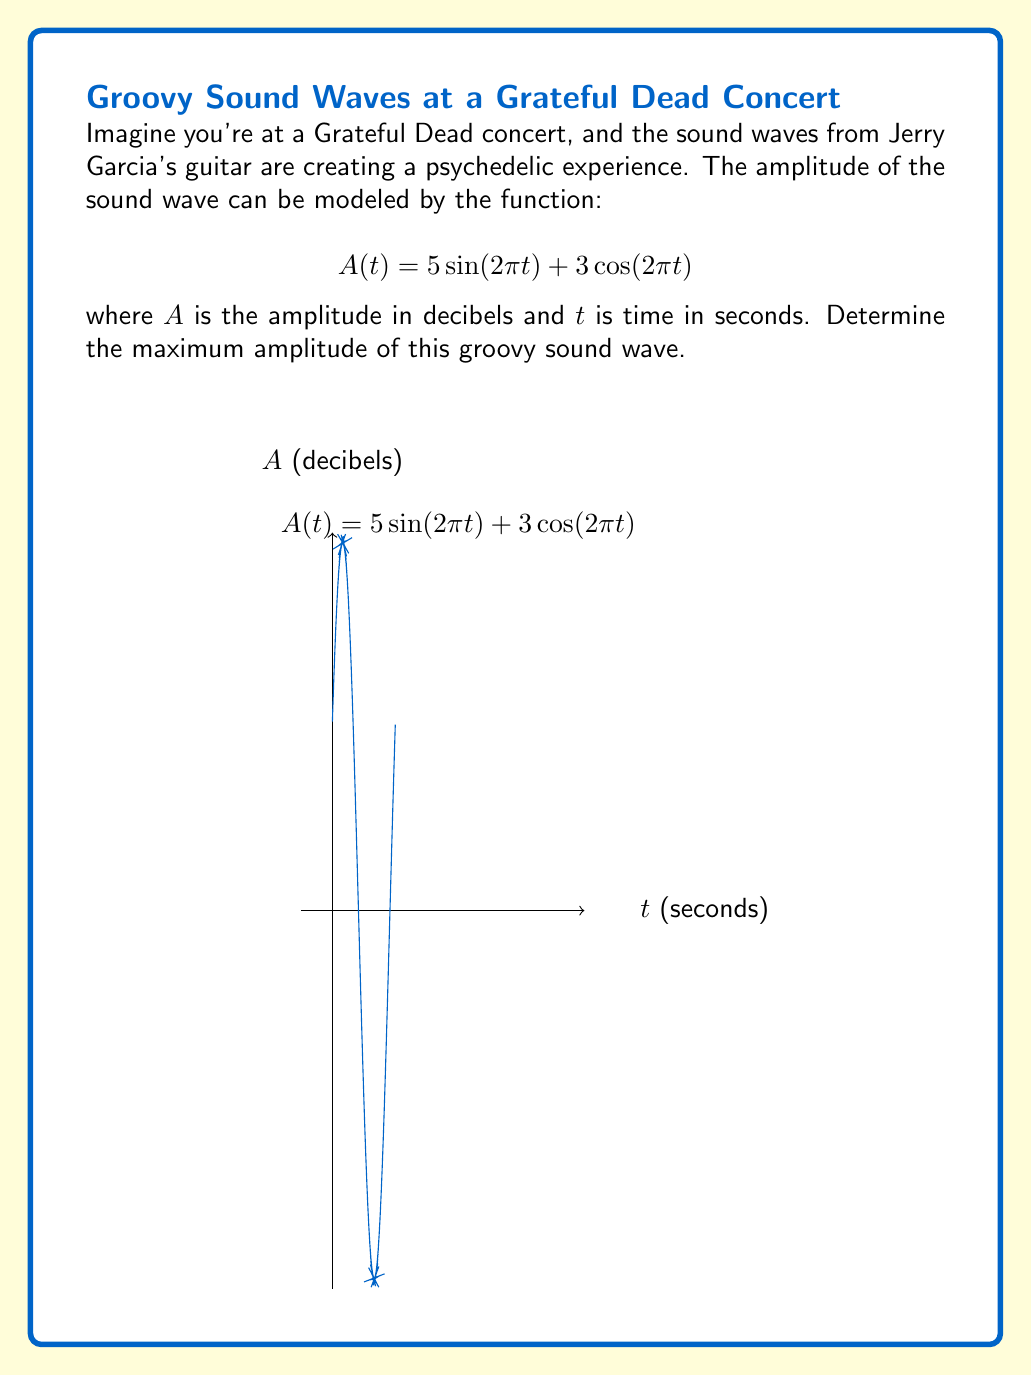Teach me how to tackle this problem. To find the maximum amplitude, we need to optimize the function $A(t)$. Here's how we can do it:

1) First, let's find the derivative of $A(t)$:
   $$A'(t) = 10\pi\cos(2\pi t) - 6\pi\sin(2\pi t)$$

2) To find the critical points, set $A'(t) = 0$:
   $$10\pi\cos(2\pi t) - 6\pi\sin(2\pi t) = 0$$

3) Divide both sides by $2\pi$:
   $$5\cos(2\pi t) - 3\sin(2\pi t) = 0$$

4) This can be solved using the substitution $\tan(2\pi t) = \frac{5}{3}$. However, we don't need to solve for $t$ explicitly.

5) Instead, we can use the identity $\sin^2(x) + \cos^2(x) = 1$ to find the maximum value directly:

   Let $\sin(2\pi t) = \frac{3}{\sqrt{34}}$ and $\cos(2\pi t) = \frac{5}{\sqrt{34}}$

6) Substitute these into the original function:

   $$A_{max} = 5\cdot\frac{3}{\sqrt{34}} + 3\cdot\frac{5}{\sqrt{34}} = \frac{15+15}{\sqrt{34}} = \frac{30}{\sqrt{34}}$$

7) Simplify:
   $$A_{max} = 5\sqrt{34} \approx 29.15 \text{ decibels}$$

This is the maximum amplitude of the sound wave.
Answer: $5\sqrt{34}$ decibels 